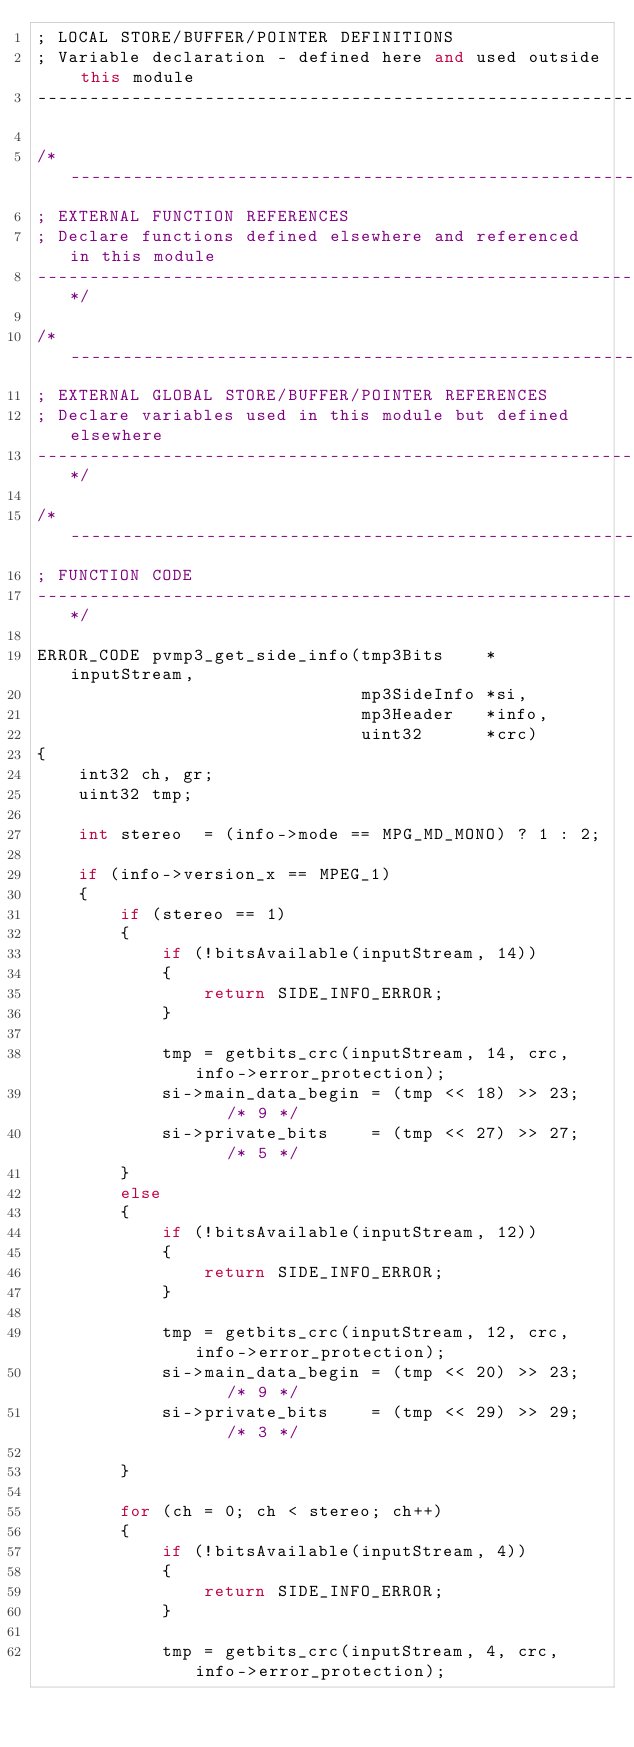<code> <loc_0><loc_0><loc_500><loc_500><_C++_>; LOCAL STORE/BUFFER/POINTER DEFINITIONS
; Variable declaration - defined here and used outside this module
----------------------------------------------------------------------------*/

/*----------------------------------------------------------------------------
; EXTERNAL FUNCTION REFERENCES
; Declare functions defined elsewhere and referenced in this module
----------------------------------------------------------------------------*/

/*----------------------------------------------------------------------------
; EXTERNAL GLOBAL STORE/BUFFER/POINTER REFERENCES
; Declare variables used in this module but defined elsewhere
----------------------------------------------------------------------------*/

/*----------------------------------------------------------------------------
; FUNCTION CODE
----------------------------------------------------------------------------*/

ERROR_CODE pvmp3_get_side_info(tmp3Bits    *inputStream,
                               mp3SideInfo *si,
                               mp3Header   *info,
                               uint32      *crc)
{
    int32 ch, gr;
    uint32 tmp;

    int stereo  = (info->mode == MPG_MD_MONO) ? 1 : 2;

    if (info->version_x == MPEG_1)
    {
        if (stereo == 1)
        {
            if (!bitsAvailable(inputStream, 14))
            {
                return SIDE_INFO_ERROR;
            }

            tmp = getbits_crc(inputStream, 14, crc, info->error_protection);
            si->main_data_begin = (tmp << 18) >> 23;    /* 9 */
            si->private_bits    = (tmp << 27) >> 27;    /* 5 */
        }
        else
        {
            if (!bitsAvailable(inputStream, 12))
            {
                return SIDE_INFO_ERROR;
            }

            tmp = getbits_crc(inputStream, 12, crc, info->error_protection);
            si->main_data_begin = (tmp << 20) >> 23;    /* 9 */
            si->private_bits    = (tmp << 29) >> 29;    /* 3 */

        }

        for (ch = 0; ch < stereo; ch++)
        {
            if (!bitsAvailable(inputStream, 4))
            {
                return SIDE_INFO_ERROR;
            }

            tmp = getbits_crc(inputStream, 4, crc, info->error_protection);</code> 